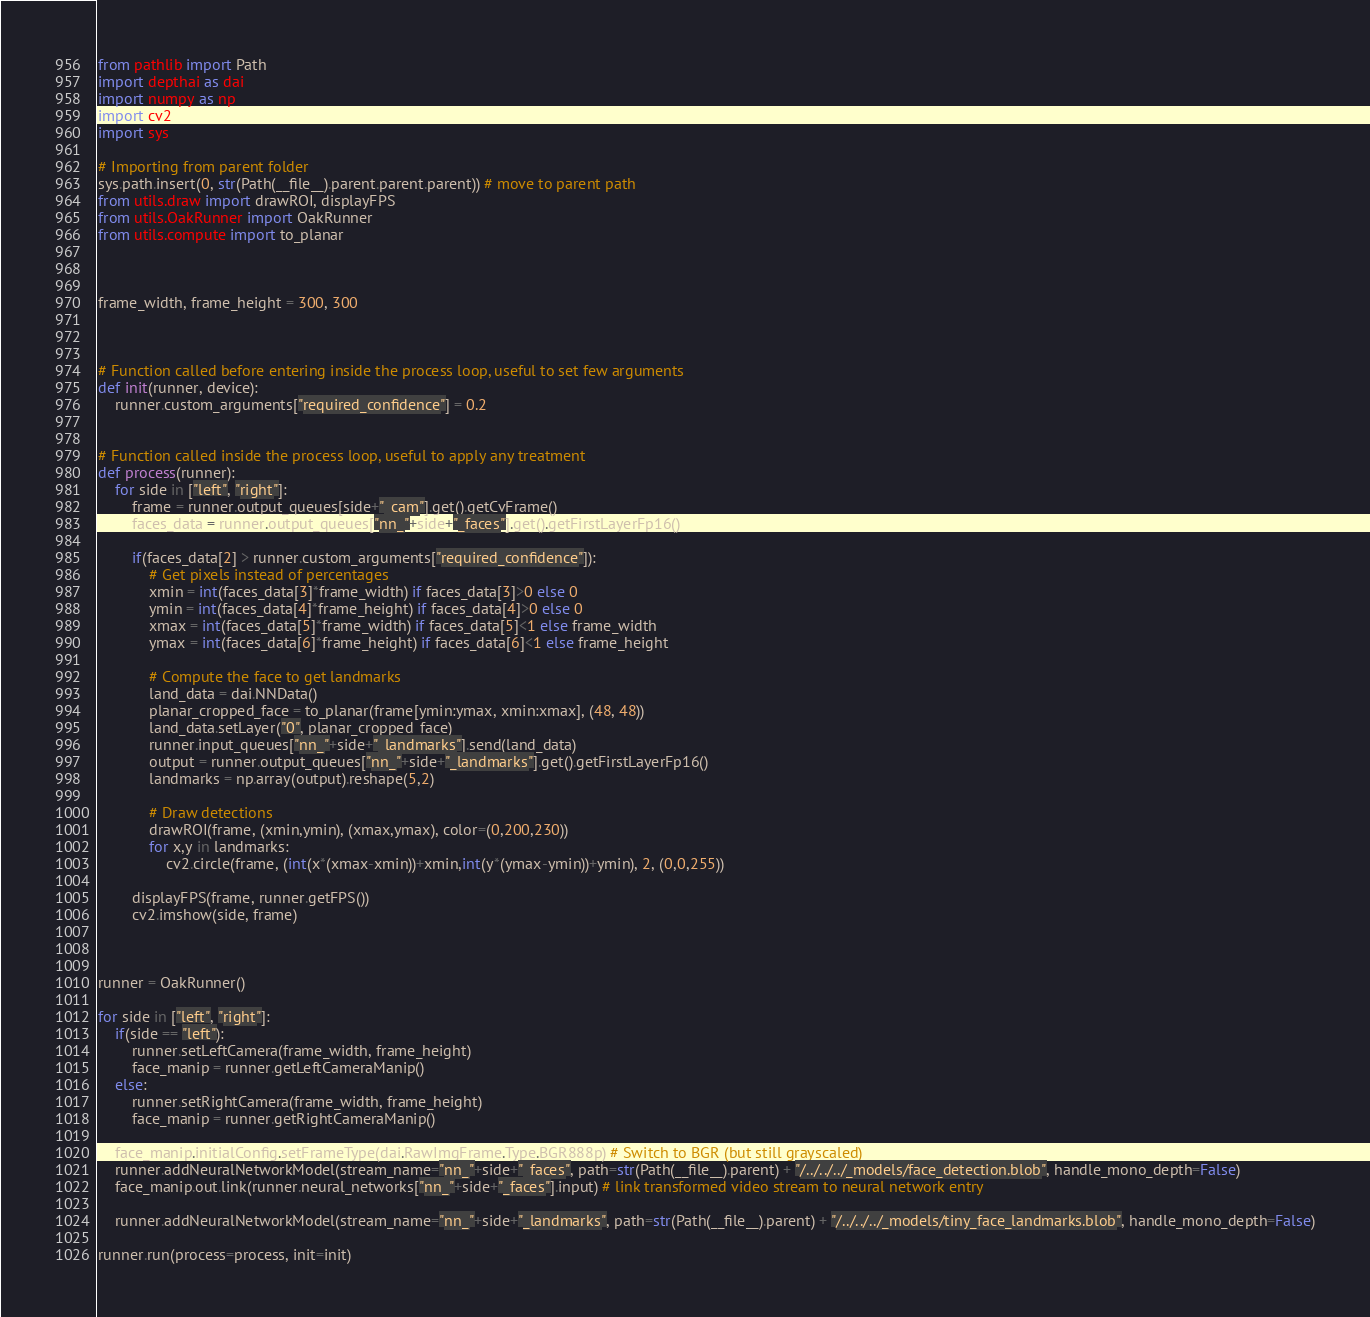Convert code to text. <code><loc_0><loc_0><loc_500><loc_500><_Python_>from pathlib import Path
import depthai as dai
import numpy as np
import cv2
import sys

# Importing from parent folder
sys.path.insert(0, str(Path(__file__).parent.parent.parent)) # move to parent path
from utils.draw import drawROI, displayFPS
from utils.OakRunner import OakRunner
from utils.compute import to_planar



frame_width, frame_height = 300, 300



# Function called before entering inside the process loop, useful to set few arguments
def init(runner, device):
    runner.custom_arguments["required_confidence"] = 0.2


# Function called inside the process loop, useful to apply any treatment
def process(runner):
    for side in ["left", "right"]:
        frame = runner.output_queues[side+"_cam"].get().getCvFrame()
        faces_data = runner.output_queues["nn_"+side+"_faces"].get().getFirstLayerFp16()

        if(faces_data[2] > runner.custom_arguments["required_confidence"]):
            # Get pixels instead of percentages
            xmin = int(faces_data[3]*frame_width) if faces_data[3]>0 else 0
            ymin = int(faces_data[4]*frame_height) if faces_data[4]>0 else 0
            xmax = int(faces_data[5]*frame_width) if faces_data[5]<1 else frame_width
            ymax = int(faces_data[6]*frame_height) if faces_data[6]<1 else frame_height

            # Compute the face to get landmarks
            land_data = dai.NNData()
            planar_cropped_face = to_planar(frame[ymin:ymax, xmin:xmax], (48, 48))
            land_data.setLayer("0", planar_cropped_face)
            runner.input_queues["nn_"+side+"_landmarks"].send(land_data)
            output = runner.output_queues["nn_"+side+"_landmarks"].get().getFirstLayerFp16()
            landmarks = np.array(output).reshape(5,2)

            # Draw detections
            drawROI(frame, (xmin,ymin), (xmax,ymax), color=(0,200,230))
            for x,y in landmarks:
                cv2.circle(frame, (int(x*(xmax-xmin))+xmin,int(y*(ymax-ymin))+ymin), 2, (0,0,255))

        displayFPS(frame, runner.getFPS())
        cv2.imshow(side, frame)



runner = OakRunner()

for side in ["left", "right"]:
    if(side == "left"):
        runner.setLeftCamera(frame_width, frame_height)
        face_manip = runner.getLeftCameraManip()
    else:
        runner.setRightCamera(frame_width, frame_height)
        face_manip = runner.getRightCameraManip()

    face_manip.initialConfig.setFrameType(dai.RawImgFrame.Type.BGR888p) # Switch to BGR (but still grayscaled)
    runner.addNeuralNetworkModel(stream_name="nn_"+side+"_faces", path=str(Path(__file__).parent) + "/../../../_models/face_detection.blob", handle_mono_depth=False)
    face_manip.out.link(runner.neural_networks["nn_"+side+"_faces"].input) # link transformed video stream to neural network entry

    runner.addNeuralNetworkModel(stream_name="nn_"+side+"_landmarks", path=str(Path(__file__).parent) + "/../../../_models/tiny_face_landmarks.blob", handle_mono_depth=False)

runner.run(process=process, init=init)</code> 